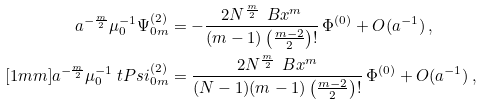Convert formula to latex. <formula><loc_0><loc_0><loc_500><loc_500>a ^ { - \frac { m } { 2 } } \mu _ { 0 } ^ { - 1 } \Psi ^ { ( 2 ) } _ { 0 m } & = - \frac { 2 N ^ { \frac { m } { 2 } } \, \ B x ^ { m } } { ( m - 1 ) \left ( \frac { m - 2 } 2 \right ) ! } \, \Phi ^ { ( 0 ) } + O ( a ^ { - 1 } ) \, , \\ [ 1 m m ] a ^ { - \frac { m } { 2 } } \mu _ { 0 } ^ { - 1 } \ t P s i ^ { ( 2 ) } _ { 0 m } & = \frac { 2 N ^ { \frac { m } { 2 } } \, \ B x ^ { m } } { ( N - 1 ) ( m - 1 ) \left ( \frac { m - 2 } 2 \right ) ! } \, \Phi ^ { ( 0 ) } + O ( a ^ { - 1 } ) \, ,</formula> 